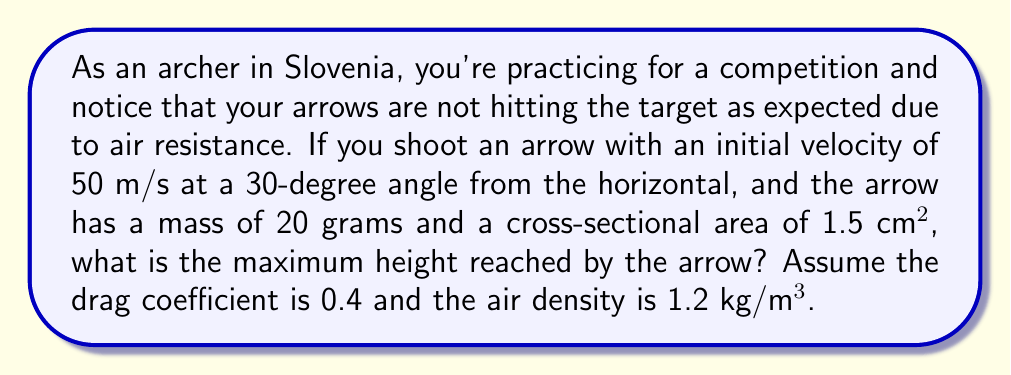What is the answer to this math problem? To solve this problem, we need to consider the effects of air resistance on the arrow's trajectory. We'll use fluid dynamics equations to model the drag force and determine the maximum height.

Step 1: Calculate the initial vertical velocity component.
$v_{y0} = v_0 \sin \theta = 50 \sin 30° = 25$ m/s

Step 2: Determine the drag force equation.
The drag force is given by:
$$F_d = \frac{1}{2} \rho C_d A v^2$$
where $\rho$ is air density, $C_d$ is drag coefficient, $A$ is cross-sectional area, and $v$ is velocity.

Step 3: Set up the equation of motion in the vertical direction.
$$m\frac{dv_y}{dt} = -mg - \frac{1}{2} \rho C_d A v_y^2$$

Step 4: Simplify by introducing a constant $k$.
Let $k = \frac{\rho C_d A}{2m}$
$k = \frac{1.2 \cdot 0.4 \cdot 0.00015}{2 \cdot 0.02} = 0.18$ m⁻¹

The equation becomes:
$$\frac{dv_y}{dt} = -g - kv_y^2$$

Step 5: Solve for the terminal velocity.
At terminal velocity, $\frac{dv_y}{dt} = 0$
$0 = -g - kv_t^2$
$v_t = \sqrt{\frac{g}{k}} = \sqrt{\frac{9.8}{0.18}} \approx 7.37$ m/s

Step 6: Use the terminal velocity to find the maximum height.
The maximum height is reached when $v_y = 0$. We can use the energy equation:
$$\frac{1}{2}mv_0^2 + mgh = \frac{1}{2}mv_t^2 \ln(\cosh(\frac{gt}{v_t}))$$

At maximum height, $t = \frac{v_0}{g}$, so:
$$h_{max} = \frac{v_t^2}{2g} \ln(\cosh(\frac{v_0}{v_t}))$$

Step 7: Calculate the maximum height.
$$h_{max} = \frac{7.37^2}{2 \cdot 9.8} \ln(\cosh(\frac{25}{7.37})) \approx 15.8$$ meters
Answer: 15.8 meters 